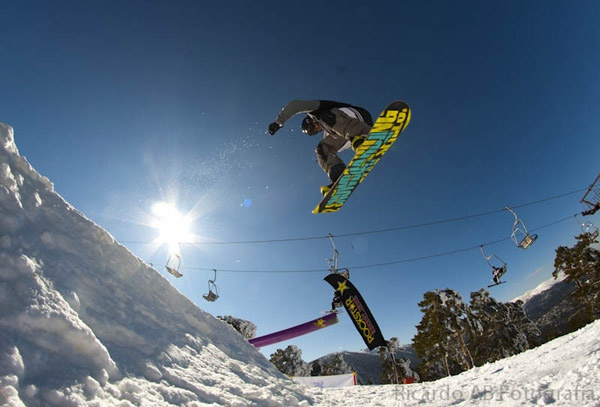Describe the objects in this image and their specific colors. I can see people in darkblue, black, gray, and blue tones, snowboard in darkblue, teal, black, and olive tones, snowboard in darkblue, black, olive, and maroon tones, people in darkblue, black, gray, and darkgray tones, and snowboard in darkblue, gray, blue, and black tones in this image. 